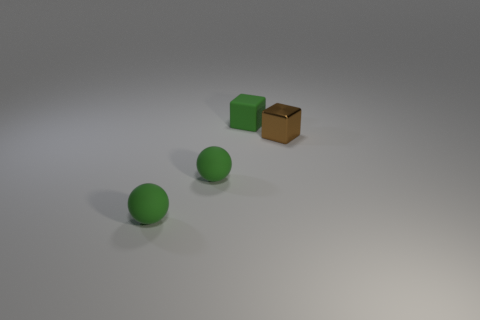Add 4 small rubber blocks. How many objects exist? 8 Subtract 0 yellow spheres. How many objects are left? 4 Subtract all large blue metal cylinders. Subtract all small brown cubes. How many objects are left? 3 Add 3 small blocks. How many small blocks are left? 5 Add 4 tiny green blocks. How many tiny green blocks exist? 5 